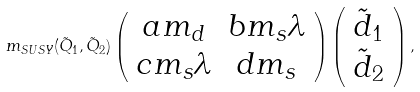<formula> <loc_0><loc_0><loc_500><loc_500>m _ { S U S Y } ( \tilde { Q } _ { 1 } , \tilde { Q } _ { 2 } ) \left ( \begin{array} { c c } a m _ { d } & b m _ { s } \lambda \\ c m _ { s } \lambda & d m _ { s } \end{array} \right ) \left ( \begin{array} { c } \tilde { d } _ { 1 } \\ \tilde { d } _ { 2 } \end{array} \right ) ,</formula> 